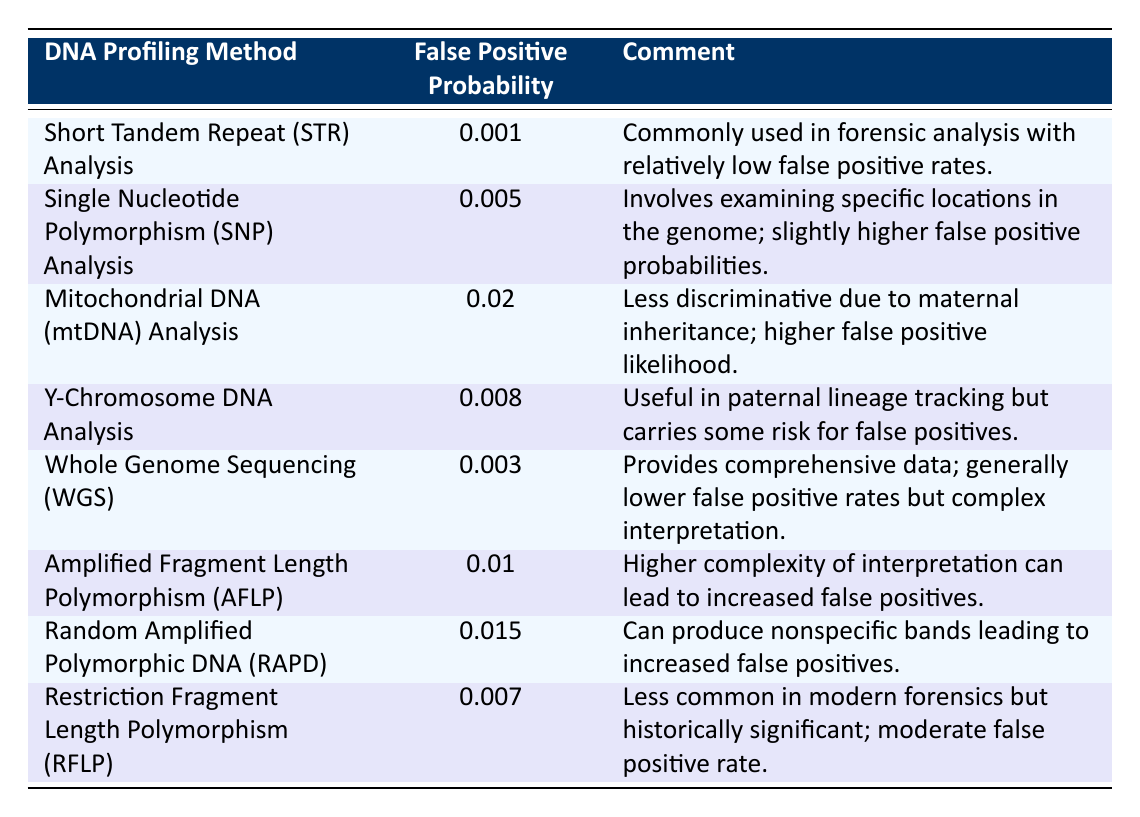What is the false positive probability for Short Tandem Repeat Analysis? The table lists the false positive probability for Short Tandem Repeat Analysis as 0.001.
Answer: 0.001 Which DNA profiling method has the highest false positive probability? By reviewing the table, Mitochondrial DNA Analysis has the highest false positive probability at 0.02.
Answer: Mitochondrial DNA Analysis How many methods have a false positive probability below 0.005? The methods with false positive probabilities are: 0.001 (STR), 0.005 (SNP), and all others are above. Only STR is below 0.005, giving us 1 method.
Answer: 1 What is the average false positive probability of Y-Chromosome Analysis and Restriction Fragment Length Polymorphism Analysis? The false positive probability for Y-Chromosome Analysis is 0.008 and for RFLP is 0.007. Adding these gives 0.008 + 0.007 = 0.015. The average is calculated by dividing by 2 (0.015 / 2 = 0.0075).
Answer: 0.0075 Is it true that Whole Genome Sequencing has a lower false positive probability than Y-Chromosome Analysis? Comparing the probabilities, Whole Genome Sequencing is 0.003 and Y-Chromosome Analysis is 0.008; since 0.003 < 0.008, the statement is true.
Answer: Yes What is the difference between the false positive probabilities of SNP Analysis and AFLP? SNP Analysis has a probability of 0.005, and AFLP has 0.01. The difference is calculated as 0.01 - 0.005 = 0.005.
Answer: 0.005 How many profiling methods have false positive probabilities greater than 0.01? The methods with probabilities greater than 0.01 are: Mitochondrial DNA (0.02), AFLP (0.01) not included, and RAPD (0.015). Counting these gives us 2 methods.
Answer: 2 Which method has a lower false positive probability: Random Amplified Polymorphic DNA or STR Analysis? The false positive probability for RAPD is 0.015 while STR has 0.001. Since 0.001 < 0.015, STR Analysis has the lower probability.
Answer: STR Analysis In total, what is the combined false positive probability for mtDNA and Y-Chromosome Analysis? The probabilities are 0.02 for mtDNA and 0.008 for Y-Chromosome Analysis. The combined total is 0.02 + 0.008 = 0.028.
Answer: 0.028 